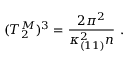Convert formula to latex. <formula><loc_0><loc_0><loc_500><loc_500>( T _ { 2 } ^ { M } ) ^ { 3 } = { \frac { 2 \pi ^ { 2 } } { \kappa _ { ( 1 1 ) } ^ { 2 } n } } \ .</formula> 